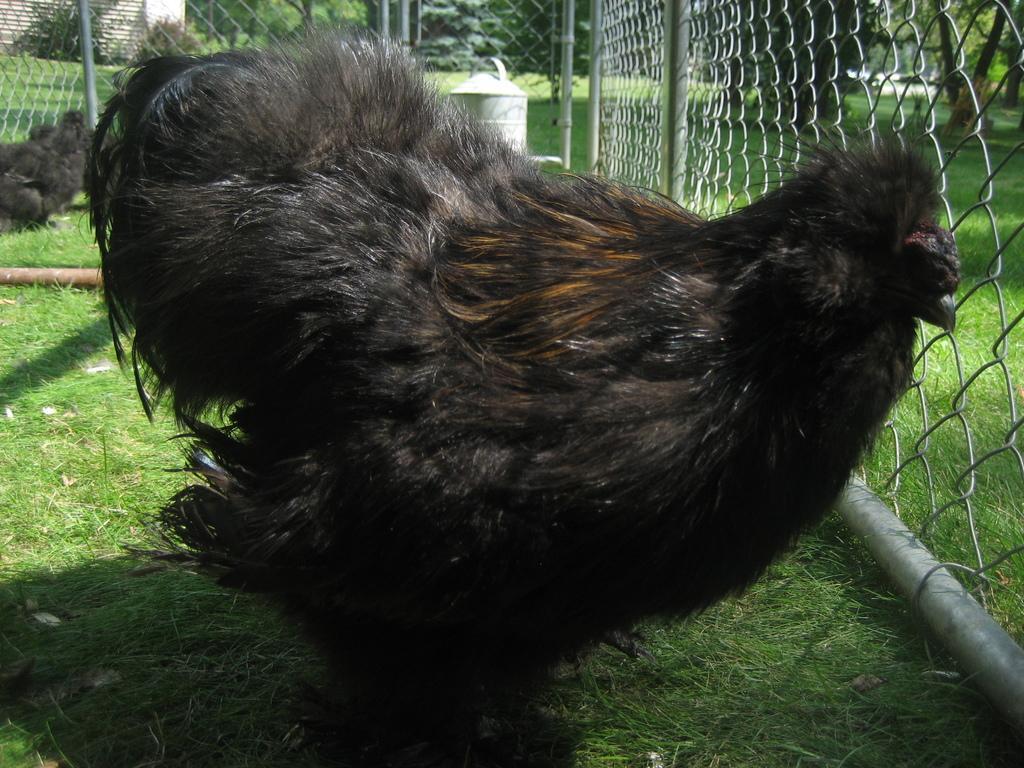Describe this image in one or two sentences. In this image there are birds. At the bottom there is grass and we can see a fence. In the background there are trees and a wall. 